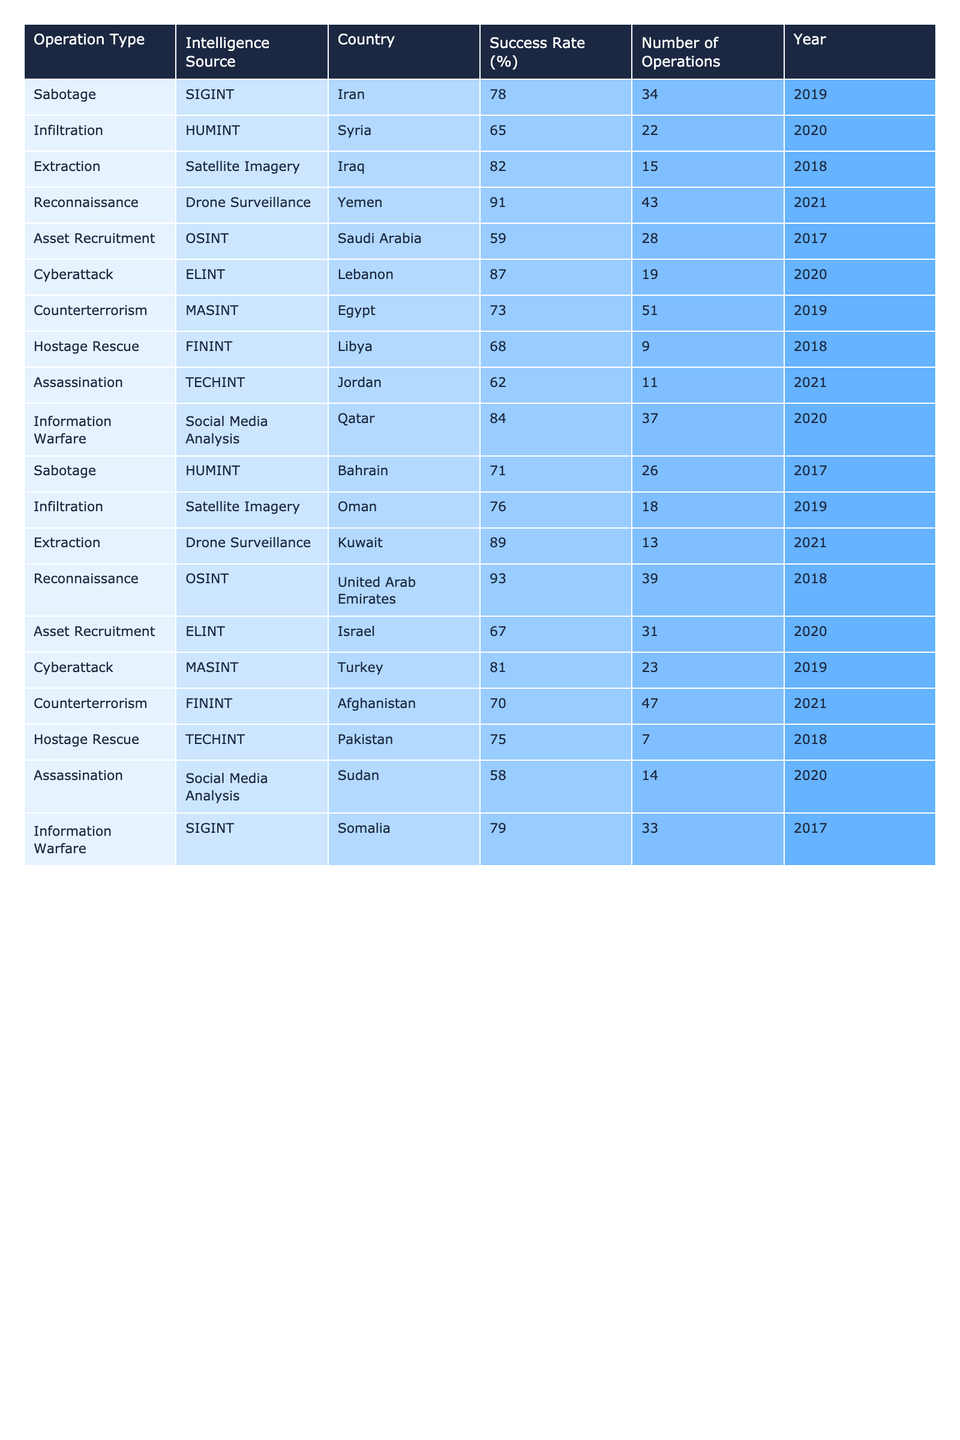What is the highest success rate for covert operations in the table? By scanning through the success rates in the table, the highest rate is 93%, which corresponds to the reconnaissance operation in the United Arab Emirates.
Answer: 93% How many operations in Iraq were successful? The table shows that there were 15 extraction operations in Iraq, with a success rate of 82%. Therefore, the successful operations can be calculated as (15 * 82/100) = 12.3, which rounds up to 12 successful operations.
Answer: 12 Which country had the lowest success rate for covert operations? By reviewing the success rates in the table, the lowest rate is 58%, which is from the assassination operation in Sudan.
Answer: Sudan Calculate the average success rate of all operations conducted in 2019. The success rates for 2019 are 78 (Iran), 73 (Egypt), and 81 (Turkey). Summing these gives 78 + 73 + 81 = 232. There are 3 operations, so the average is 232/3 = 77.33.
Answer: 77.33 Did covert operations using HUMINT have a higher or lower success rate than those using OSINT? The success rate for HUMINT (using Syria and Bahrain) is (65 + 71) / 2 = 68%. The OSINT success rate (using Saudi Arabia and UAE) is (59 + 93) / 2 = 76%. Since 68% is lower than 76%, HUMINT had a lower success rate.
Answer: Lower List the number of operations with a success rate above 80%. The operations with success rates above 80% are: extraction in Iraq (82%), reconnaissance in Yemen (91%), cyberattack in Lebanon (87%), extraction in Kuwait (89%), and reconnaissance in the UAE (93%). Counting these gives a total of 5 operations.
Answer: 5 Which operation type has the highest success rate and what is that rate? The reconnaissance operation in the United Arab Emirates has the highest success rate of 93%, as identified from the table's data.
Answer: Reconnaissance, 93% What was the total number of operations conducted in 2020? The operations conducted in 2020 are: infiltration in Syria (22), cyberattack in Lebanon (19), and information warfare in Qatar (37). Summing these gives a total of 22 + 19 + 37 = 78 operations.
Answer: 78 Is the success rate for cyberattacks generally higher than that for sabotage operations? The success rates indicate a cyberattack rate of 87% (Lebanon) and sabotage rates of 78% (Iran) and 71% (Bahrain). Since 87% is greater than both values of sabotage, it is correct that cyberattacks generally have a higher rate.
Answer: Yes Which two countries had covert operations with a success rate of at least 90%? The countries are Yemen (reconnaissance operation with 91%) and UAE (reconnaissance operation with 93%). Both had success rates above 90%.
Answer: Yemen, UAE 